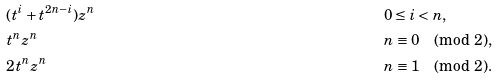Convert formula to latex. <formula><loc_0><loc_0><loc_500><loc_500>& ( t ^ { i } + t ^ { 2 n - i } ) z ^ { n } & & 0 \leq i < n , \\ & t ^ { n } z ^ { n } & & n \equiv 0 \pmod { 2 } , \\ & 2 t ^ { n } z ^ { n } & & n \equiv 1 \pmod { 2 } .</formula> 